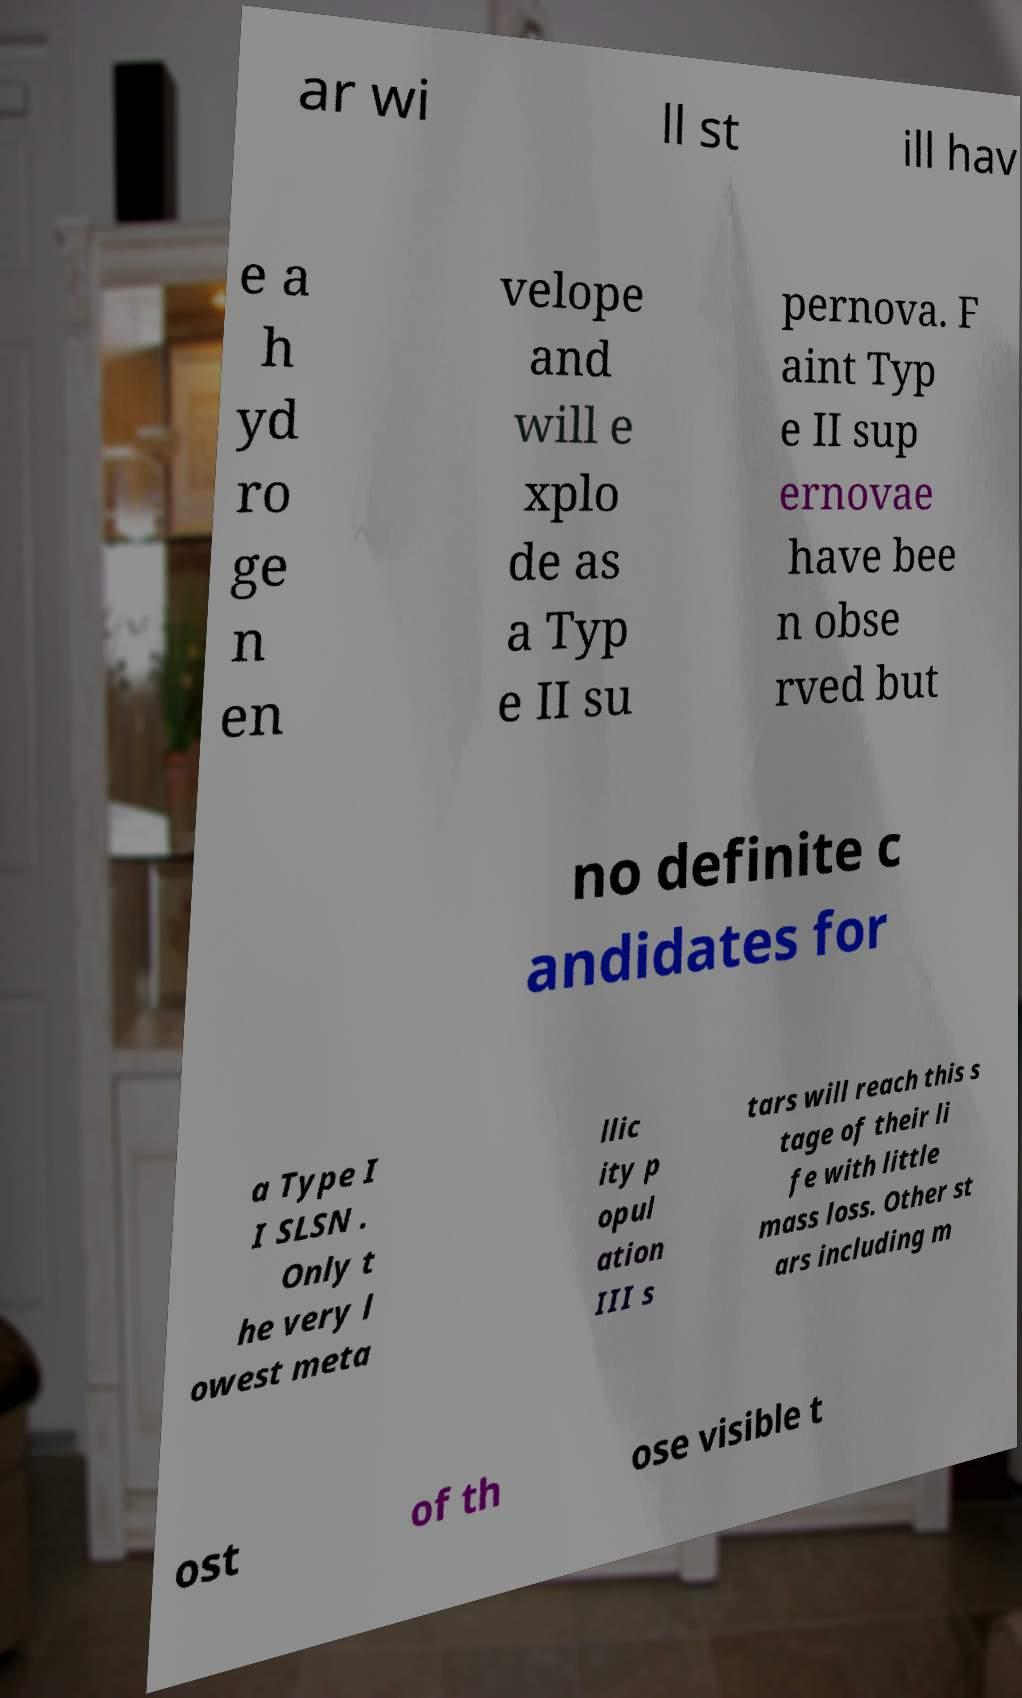I need the written content from this picture converted into text. Can you do that? ar wi ll st ill hav e a h yd ro ge n en velope and will e xplo de as a Typ e II su pernova. F aint Typ e II sup ernovae have bee n obse rved but no definite c andidates for a Type I I SLSN . Only t he very l owest meta llic ity p opul ation III s tars will reach this s tage of their li fe with little mass loss. Other st ars including m ost of th ose visible t 